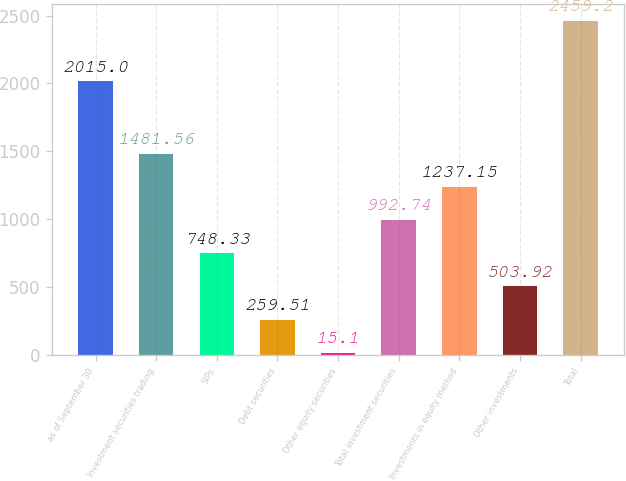<chart> <loc_0><loc_0><loc_500><loc_500><bar_chart><fcel>as of September 30<fcel>Investment securities trading<fcel>SIPs<fcel>Debt securities<fcel>Other equity securities<fcel>Total investment securities<fcel>Investments in equity method<fcel>Other investments<fcel>Total<nl><fcel>2015<fcel>1481.56<fcel>748.33<fcel>259.51<fcel>15.1<fcel>992.74<fcel>1237.15<fcel>503.92<fcel>2459.2<nl></chart> 